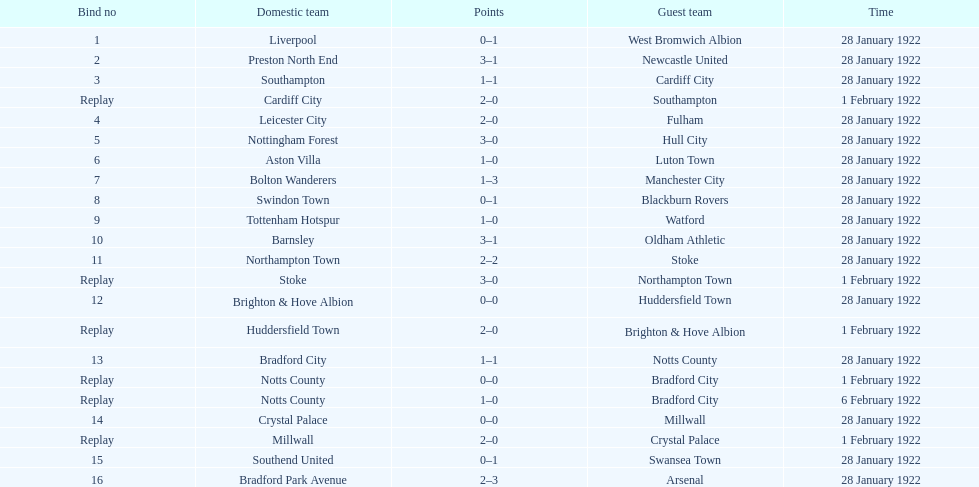Could you parse the entire table? {'header': ['Bind no', 'Domestic team', 'Points', 'Guest team', 'Time'], 'rows': [['1', 'Liverpool', '0–1', 'West Bromwich Albion', '28 January 1922'], ['2', 'Preston North End', '3–1', 'Newcastle United', '28 January 1922'], ['3', 'Southampton', '1–1', 'Cardiff City', '28 January 1922'], ['Replay', 'Cardiff City', '2–0', 'Southampton', '1 February 1922'], ['4', 'Leicester City', '2–0', 'Fulham', '28 January 1922'], ['5', 'Nottingham Forest', '3–0', 'Hull City', '28 January 1922'], ['6', 'Aston Villa', '1–0', 'Luton Town', '28 January 1922'], ['7', 'Bolton Wanderers', '1–3', 'Manchester City', '28 January 1922'], ['8', 'Swindon Town', '0–1', 'Blackburn Rovers', '28 January 1922'], ['9', 'Tottenham Hotspur', '1–0', 'Watford', '28 January 1922'], ['10', 'Barnsley', '3–1', 'Oldham Athletic', '28 January 1922'], ['11', 'Northampton Town', '2–2', 'Stoke', '28 January 1922'], ['Replay', 'Stoke', '3–0', 'Northampton Town', '1 February 1922'], ['12', 'Brighton & Hove Albion', '0–0', 'Huddersfield Town', '28 January 1922'], ['Replay', 'Huddersfield Town', '2–0', 'Brighton & Hove Albion', '1 February 1922'], ['13', 'Bradford City', '1–1', 'Notts County', '28 January 1922'], ['Replay', 'Notts County', '0–0', 'Bradford City', '1 February 1922'], ['Replay', 'Notts County', '1–0', 'Bradford City', '6 February 1922'], ['14', 'Crystal Palace', '0–0', 'Millwall', '28 January 1922'], ['Replay', 'Millwall', '2–0', 'Crystal Palace', '1 February 1922'], ['15', 'Southend United', '0–1', 'Swansea Town', '28 January 1922'], ['16', 'Bradford Park Avenue', '2–3', 'Arsenal', '28 January 1922']]} What date did they play before feb 1? 28 January 1922. 